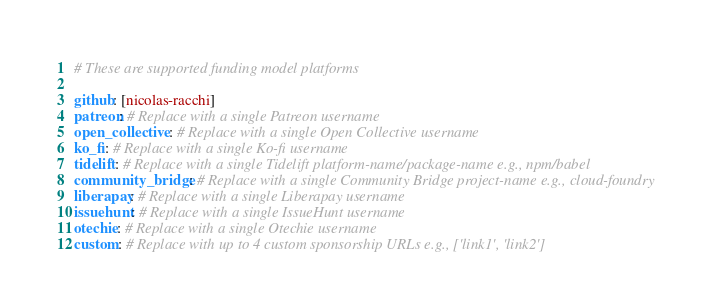<code> <loc_0><loc_0><loc_500><loc_500><_YAML_># These are supported funding model platforms

github: [nicolas-racchi]
patreon: # Replace with a single Patreon username
open_collective: # Replace with a single Open Collective username
ko_fi: # Replace with a single Ko-fi username
tidelift: # Replace with a single Tidelift platform-name/package-name e.g., npm/babel
community_bridge: # Replace with a single Community Bridge project-name e.g., cloud-foundry
liberapay: # Replace with a single Liberapay username
issuehunt: # Replace with a single IssueHunt username
otechie: # Replace with a single Otechie username
custom: # Replace with up to 4 custom sponsorship URLs e.g., ['link1', 'link2']
</code> 